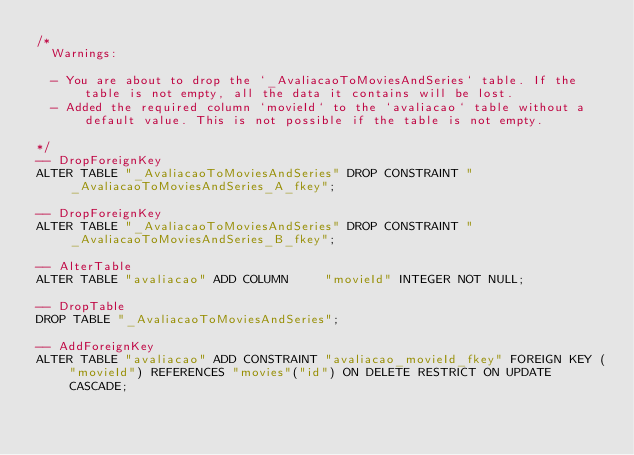Convert code to text. <code><loc_0><loc_0><loc_500><loc_500><_SQL_>/*
  Warnings:

  - You are about to drop the `_AvaliacaoToMoviesAndSeries` table. If the table is not empty, all the data it contains will be lost.
  - Added the required column `movieId` to the `avaliacao` table without a default value. This is not possible if the table is not empty.

*/
-- DropForeignKey
ALTER TABLE "_AvaliacaoToMoviesAndSeries" DROP CONSTRAINT "_AvaliacaoToMoviesAndSeries_A_fkey";

-- DropForeignKey
ALTER TABLE "_AvaliacaoToMoviesAndSeries" DROP CONSTRAINT "_AvaliacaoToMoviesAndSeries_B_fkey";

-- AlterTable
ALTER TABLE "avaliacao" ADD COLUMN     "movieId" INTEGER NOT NULL;

-- DropTable
DROP TABLE "_AvaliacaoToMoviesAndSeries";

-- AddForeignKey
ALTER TABLE "avaliacao" ADD CONSTRAINT "avaliacao_movieId_fkey" FOREIGN KEY ("movieId") REFERENCES "movies"("id") ON DELETE RESTRICT ON UPDATE CASCADE;
</code> 